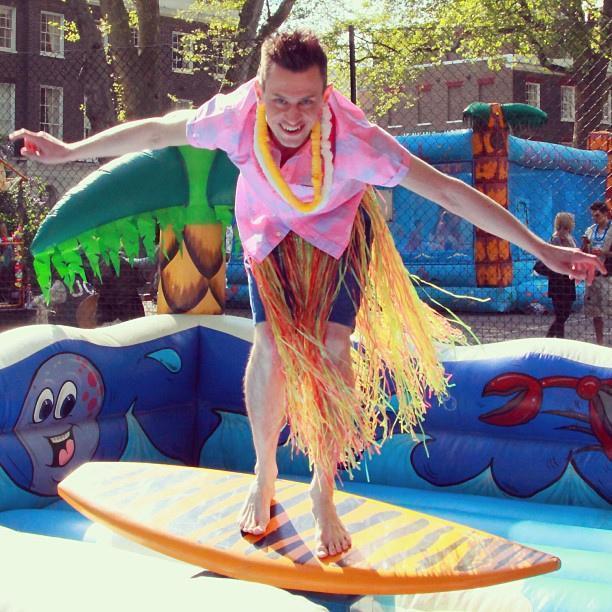How many people are visible?
Give a very brief answer. 3. 